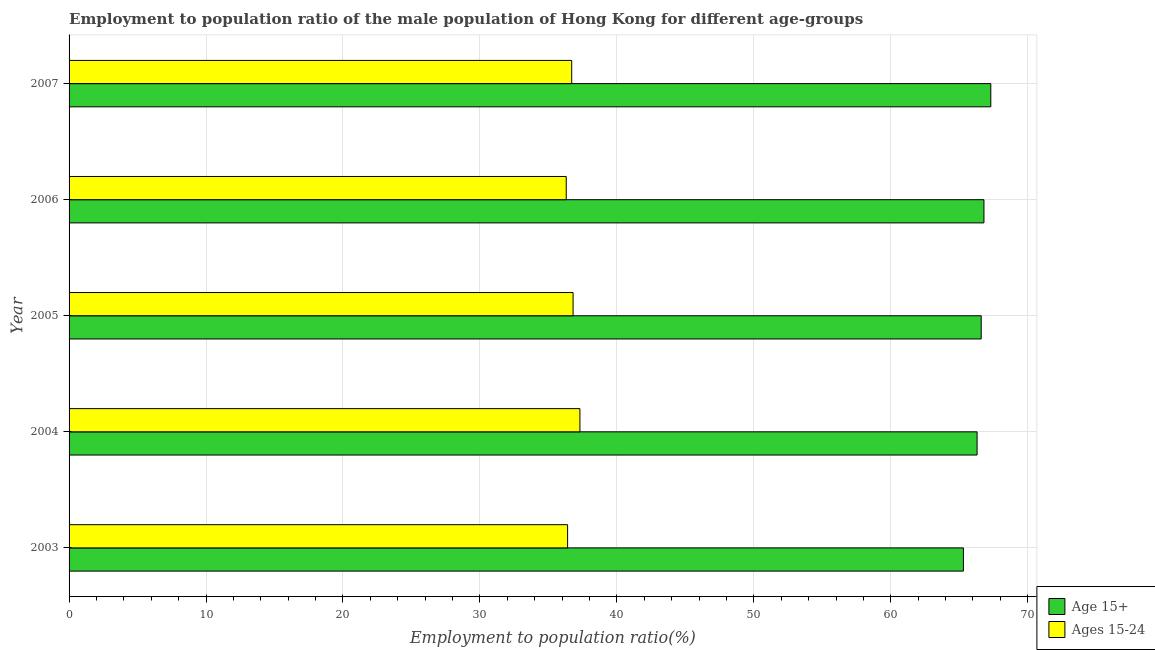How many different coloured bars are there?
Ensure brevity in your answer.  2. How many groups of bars are there?
Provide a succinct answer. 5. Are the number of bars per tick equal to the number of legend labels?
Your response must be concise. Yes. How many bars are there on the 1st tick from the top?
Offer a very short reply. 2. What is the employment to population ratio(age 15-24) in 2005?
Provide a succinct answer. 36.8. Across all years, what is the maximum employment to population ratio(age 15+)?
Offer a very short reply. 67.3. Across all years, what is the minimum employment to population ratio(age 15+)?
Provide a succinct answer. 65.3. What is the total employment to population ratio(age 15-24) in the graph?
Provide a succinct answer. 183.5. What is the difference between the employment to population ratio(age 15-24) in 2003 and the employment to population ratio(age 15+) in 2006?
Provide a short and direct response. -30.4. What is the average employment to population ratio(age 15-24) per year?
Your answer should be very brief. 36.7. In the year 2003, what is the difference between the employment to population ratio(age 15-24) and employment to population ratio(age 15+)?
Provide a short and direct response. -28.9. In how many years, is the employment to population ratio(age 15+) greater than 36 %?
Your answer should be compact. 5. Is the employment to population ratio(age 15-24) in 2003 less than that in 2006?
Offer a very short reply. No. Is the difference between the employment to population ratio(age 15-24) in 2005 and 2007 greater than the difference between the employment to population ratio(age 15+) in 2005 and 2007?
Your answer should be very brief. Yes. What is the difference between the highest and the second highest employment to population ratio(age 15+)?
Provide a short and direct response. 0.5. Is the sum of the employment to population ratio(age 15-24) in 2004 and 2007 greater than the maximum employment to population ratio(age 15+) across all years?
Give a very brief answer. Yes. What does the 2nd bar from the top in 2004 represents?
Your response must be concise. Age 15+. What does the 2nd bar from the bottom in 2007 represents?
Provide a succinct answer. Ages 15-24. How many years are there in the graph?
Your response must be concise. 5. Does the graph contain any zero values?
Provide a short and direct response. No. Where does the legend appear in the graph?
Provide a short and direct response. Bottom right. How many legend labels are there?
Your answer should be compact. 2. What is the title of the graph?
Your answer should be compact. Employment to population ratio of the male population of Hong Kong for different age-groups. Does "Investment" appear as one of the legend labels in the graph?
Provide a short and direct response. No. What is the label or title of the X-axis?
Provide a succinct answer. Employment to population ratio(%). What is the Employment to population ratio(%) in Age 15+ in 2003?
Your response must be concise. 65.3. What is the Employment to population ratio(%) of Ages 15-24 in 2003?
Your answer should be very brief. 36.4. What is the Employment to population ratio(%) of Age 15+ in 2004?
Give a very brief answer. 66.3. What is the Employment to population ratio(%) in Ages 15-24 in 2004?
Give a very brief answer. 37.3. What is the Employment to population ratio(%) of Age 15+ in 2005?
Your answer should be very brief. 66.6. What is the Employment to population ratio(%) in Ages 15-24 in 2005?
Offer a terse response. 36.8. What is the Employment to population ratio(%) in Age 15+ in 2006?
Make the answer very short. 66.8. What is the Employment to population ratio(%) in Ages 15-24 in 2006?
Provide a short and direct response. 36.3. What is the Employment to population ratio(%) of Age 15+ in 2007?
Provide a succinct answer. 67.3. What is the Employment to population ratio(%) in Ages 15-24 in 2007?
Keep it short and to the point. 36.7. Across all years, what is the maximum Employment to population ratio(%) in Age 15+?
Make the answer very short. 67.3. Across all years, what is the maximum Employment to population ratio(%) of Ages 15-24?
Provide a succinct answer. 37.3. Across all years, what is the minimum Employment to population ratio(%) of Age 15+?
Ensure brevity in your answer.  65.3. Across all years, what is the minimum Employment to population ratio(%) of Ages 15-24?
Offer a very short reply. 36.3. What is the total Employment to population ratio(%) of Age 15+ in the graph?
Provide a short and direct response. 332.3. What is the total Employment to population ratio(%) in Ages 15-24 in the graph?
Offer a terse response. 183.5. What is the difference between the Employment to population ratio(%) of Ages 15-24 in 2003 and that in 2004?
Offer a very short reply. -0.9. What is the difference between the Employment to population ratio(%) in Ages 15-24 in 2003 and that in 2005?
Give a very brief answer. -0.4. What is the difference between the Employment to population ratio(%) in Age 15+ in 2003 and that in 2006?
Offer a very short reply. -1.5. What is the difference between the Employment to population ratio(%) in Ages 15-24 in 2004 and that in 2005?
Ensure brevity in your answer.  0.5. What is the difference between the Employment to population ratio(%) of Ages 15-24 in 2004 and that in 2007?
Provide a short and direct response. 0.6. What is the difference between the Employment to population ratio(%) of Age 15+ in 2005 and that in 2006?
Provide a short and direct response. -0.2. What is the difference between the Employment to population ratio(%) of Ages 15-24 in 2005 and that in 2006?
Make the answer very short. 0.5. What is the difference between the Employment to population ratio(%) in Ages 15-24 in 2005 and that in 2007?
Make the answer very short. 0.1. What is the difference between the Employment to population ratio(%) of Age 15+ in 2003 and the Employment to population ratio(%) of Ages 15-24 in 2004?
Keep it short and to the point. 28. What is the difference between the Employment to population ratio(%) of Age 15+ in 2003 and the Employment to population ratio(%) of Ages 15-24 in 2007?
Offer a very short reply. 28.6. What is the difference between the Employment to population ratio(%) in Age 15+ in 2004 and the Employment to population ratio(%) in Ages 15-24 in 2005?
Make the answer very short. 29.5. What is the difference between the Employment to population ratio(%) in Age 15+ in 2004 and the Employment to population ratio(%) in Ages 15-24 in 2007?
Make the answer very short. 29.6. What is the difference between the Employment to population ratio(%) of Age 15+ in 2005 and the Employment to population ratio(%) of Ages 15-24 in 2006?
Provide a short and direct response. 30.3. What is the difference between the Employment to population ratio(%) in Age 15+ in 2005 and the Employment to population ratio(%) in Ages 15-24 in 2007?
Your answer should be compact. 29.9. What is the difference between the Employment to population ratio(%) in Age 15+ in 2006 and the Employment to population ratio(%) in Ages 15-24 in 2007?
Provide a succinct answer. 30.1. What is the average Employment to population ratio(%) of Age 15+ per year?
Your answer should be very brief. 66.46. What is the average Employment to population ratio(%) in Ages 15-24 per year?
Keep it short and to the point. 36.7. In the year 2003, what is the difference between the Employment to population ratio(%) of Age 15+ and Employment to population ratio(%) of Ages 15-24?
Offer a very short reply. 28.9. In the year 2005, what is the difference between the Employment to population ratio(%) of Age 15+ and Employment to population ratio(%) of Ages 15-24?
Your response must be concise. 29.8. In the year 2006, what is the difference between the Employment to population ratio(%) in Age 15+ and Employment to population ratio(%) in Ages 15-24?
Provide a short and direct response. 30.5. In the year 2007, what is the difference between the Employment to population ratio(%) in Age 15+ and Employment to population ratio(%) in Ages 15-24?
Provide a short and direct response. 30.6. What is the ratio of the Employment to population ratio(%) in Age 15+ in 2003 to that in 2004?
Your answer should be very brief. 0.98. What is the ratio of the Employment to population ratio(%) of Ages 15-24 in 2003 to that in 2004?
Provide a succinct answer. 0.98. What is the ratio of the Employment to population ratio(%) in Age 15+ in 2003 to that in 2005?
Your answer should be compact. 0.98. What is the ratio of the Employment to population ratio(%) in Age 15+ in 2003 to that in 2006?
Your answer should be very brief. 0.98. What is the ratio of the Employment to population ratio(%) in Ages 15-24 in 2003 to that in 2006?
Your answer should be very brief. 1. What is the ratio of the Employment to population ratio(%) of Age 15+ in 2003 to that in 2007?
Your answer should be very brief. 0.97. What is the ratio of the Employment to population ratio(%) of Ages 15-24 in 2003 to that in 2007?
Your answer should be compact. 0.99. What is the ratio of the Employment to population ratio(%) of Ages 15-24 in 2004 to that in 2005?
Keep it short and to the point. 1.01. What is the ratio of the Employment to population ratio(%) in Ages 15-24 in 2004 to that in 2006?
Offer a terse response. 1.03. What is the ratio of the Employment to population ratio(%) in Age 15+ in 2004 to that in 2007?
Keep it short and to the point. 0.99. What is the ratio of the Employment to population ratio(%) in Ages 15-24 in 2004 to that in 2007?
Provide a short and direct response. 1.02. What is the ratio of the Employment to population ratio(%) in Age 15+ in 2005 to that in 2006?
Your response must be concise. 1. What is the ratio of the Employment to population ratio(%) of Ages 15-24 in 2005 to that in 2006?
Your answer should be compact. 1.01. What is the ratio of the Employment to population ratio(%) in Age 15+ in 2006 to that in 2007?
Your response must be concise. 0.99. What is the ratio of the Employment to population ratio(%) of Ages 15-24 in 2006 to that in 2007?
Provide a short and direct response. 0.99. What is the difference between the highest and the second highest Employment to population ratio(%) of Age 15+?
Make the answer very short. 0.5. What is the difference between the highest and the second highest Employment to population ratio(%) in Ages 15-24?
Your response must be concise. 0.5. What is the difference between the highest and the lowest Employment to population ratio(%) of Age 15+?
Your answer should be very brief. 2. What is the difference between the highest and the lowest Employment to population ratio(%) of Ages 15-24?
Offer a very short reply. 1. 